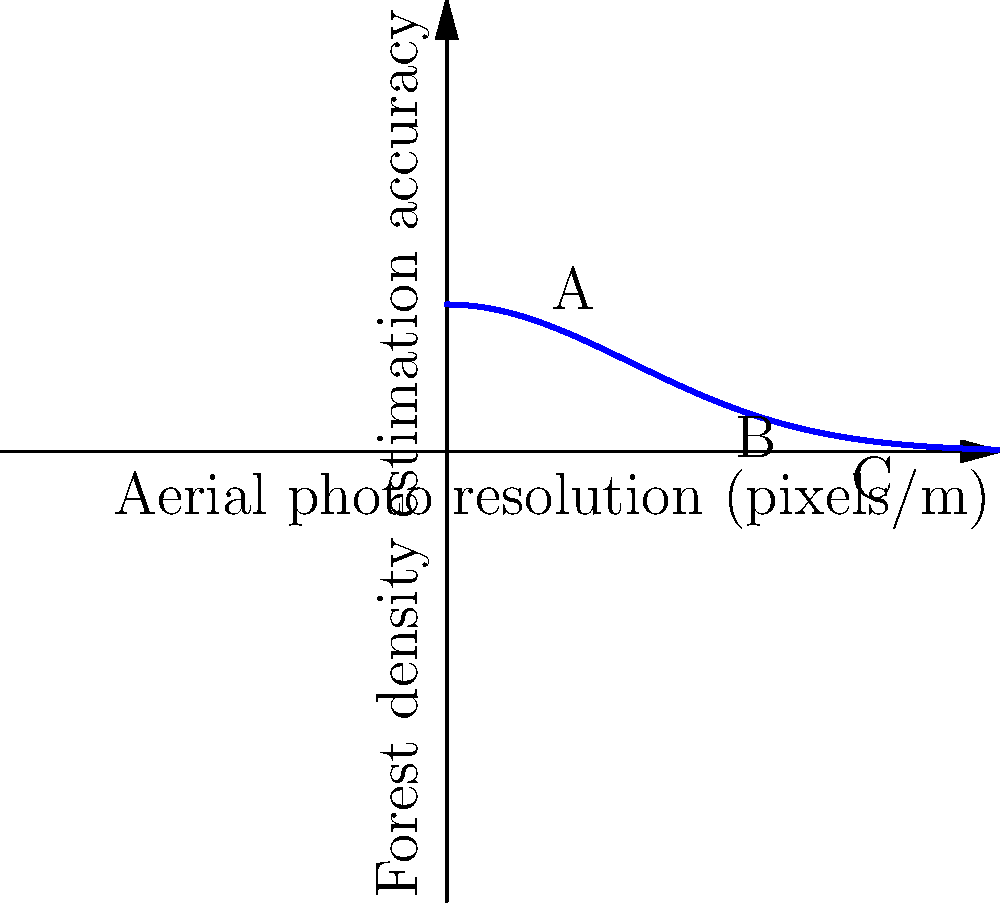Based on the graph showing the relationship between aerial photo resolution and forest density estimation accuracy, which point represents the optimal balance between resolution and accuracy for communicating forest density to the public? To determine the optimal balance between aerial photo resolution and forest density estimation accuracy for public communication, we need to consider the following steps:

1. Understand the graph:
   - X-axis represents aerial photo resolution in pixels/m
   - Y-axis represents forest density estimation accuracy
   - The curve shows a relationship where accuracy increases rapidly at first, then levels off

2. Analyze the three marked points:
   - Point A: Low resolution, moderate accuracy
   - Point B: Medium resolution, high accuracy
   - Point C: High resolution, slightly higher accuracy than B

3. Consider the trade-offs:
   - Higher resolution typically means more expensive and time-consuming data collection
   - Diminishing returns in accuracy as resolution increases

4. Think about the journalist's goal:
   - Making the ecologist's research accessible to the public
   - Balance between accuracy and simplicity

5. Choose the optimal point:
   - Point B offers a good balance between resolution and accuracy
   - It provides high accuracy without the excessive cost and complexity of point C
   - It's significantly better than point A in terms of accuracy

6. Justify for public communication:
   - Point B provides sufficient accuracy for public understanding
   - It avoids overwhelming the audience with unnecessarily high-resolution data

Therefore, point B represents the optimal balance between resolution and accuracy for communicating forest density to the public.
Answer: Point B 